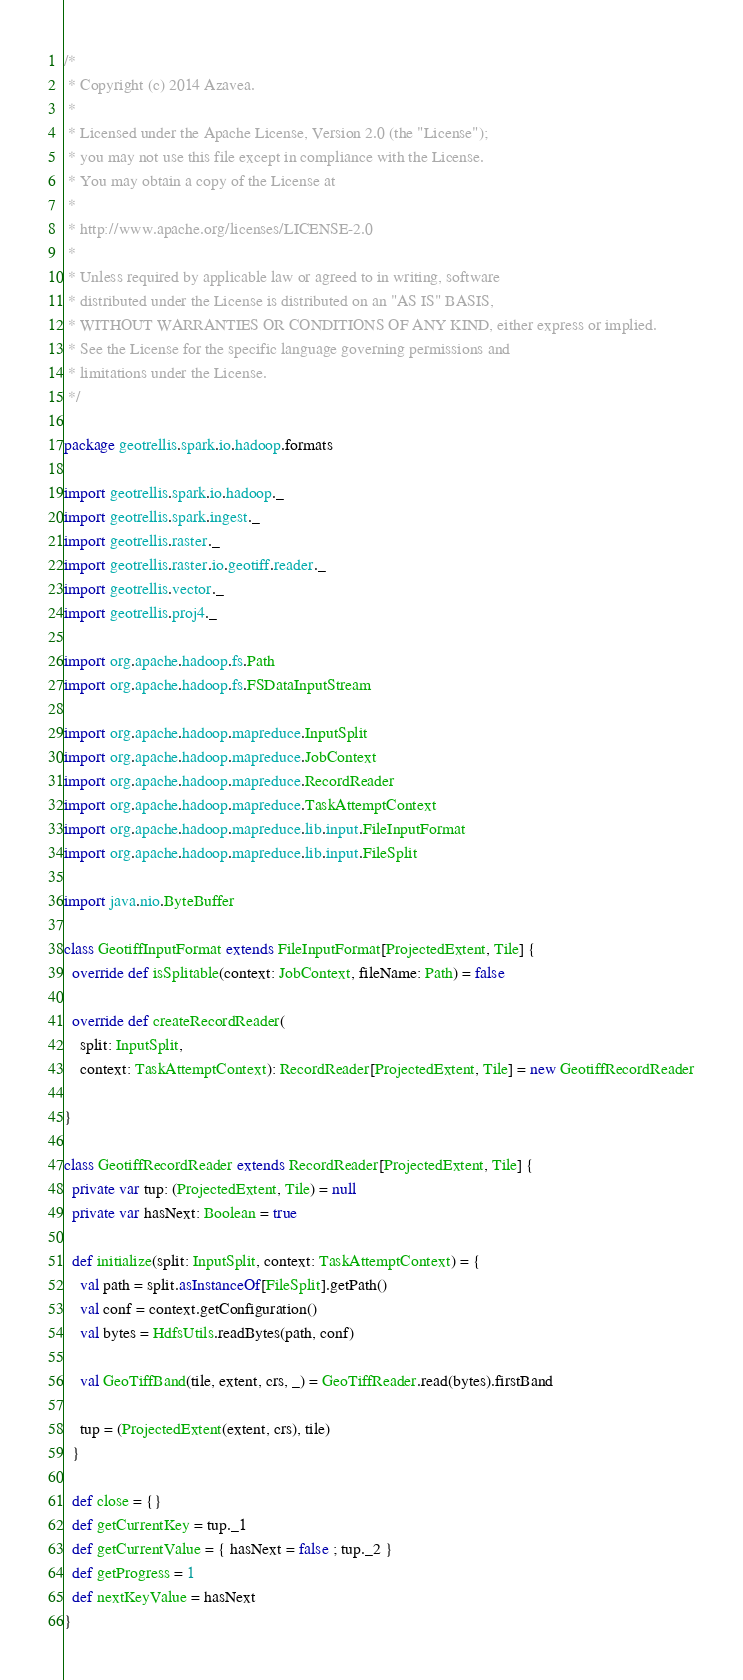<code> <loc_0><loc_0><loc_500><loc_500><_Scala_>/*
 * Copyright (c) 2014 Azavea.
 *
 * Licensed under the Apache License, Version 2.0 (the "License");
 * you may not use this file except in compliance with the License.
 * You may obtain a copy of the License at
 *
 * http://www.apache.org/licenses/LICENSE-2.0
 *
 * Unless required by applicable law or agreed to in writing, software
 * distributed under the License is distributed on an "AS IS" BASIS,
 * WITHOUT WARRANTIES OR CONDITIONS OF ANY KIND, either express or implied.
 * See the License for the specific language governing permissions and
 * limitations under the License.
 */

package geotrellis.spark.io.hadoop.formats

import geotrellis.spark.io.hadoop._
import geotrellis.spark.ingest._
import geotrellis.raster._
import geotrellis.raster.io.geotiff.reader._
import geotrellis.vector._
import geotrellis.proj4._

import org.apache.hadoop.fs.Path
import org.apache.hadoop.fs.FSDataInputStream

import org.apache.hadoop.mapreduce.InputSplit
import org.apache.hadoop.mapreduce.JobContext
import org.apache.hadoop.mapreduce.RecordReader
import org.apache.hadoop.mapreduce.TaskAttemptContext
import org.apache.hadoop.mapreduce.lib.input.FileInputFormat
import org.apache.hadoop.mapreduce.lib.input.FileSplit

import java.nio.ByteBuffer

class GeotiffInputFormat extends FileInputFormat[ProjectedExtent, Tile] {
  override def isSplitable(context: JobContext, fileName: Path) = false

  override def createRecordReader(
    split: InputSplit,
    context: TaskAttemptContext): RecordReader[ProjectedExtent, Tile] = new GeotiffRecordReader

}

class GeotiffRecordReader extends RecordReader[ProjectedExtent, Tile] {
  private var tup: (ProjectedExtent, Tile) = null
  private var hasNext: Boolean = true

  def initialize(split: InputSplit, context: TaskAttemptContext) = {
    val path = split.asInstanceOf[FileSplit].getPath()
    val conf = context.getConfiguration()
    val bytes = HdfsUtils.readBytes(path, conf)

    val GeoTiffBand(tile, extent, crs, _) = GeoTiffReader.read(bytes).firstBand

    tup = (ProjectedExtent(extent, crs), tile)
  }

  def close = {}
  def getCurrentKey = tup._1
  def getCurrentValue = { hasNext = false ; tup._2 }
  def getProgress = 1
  def nextKeyValue = hasNext
}
</code> 